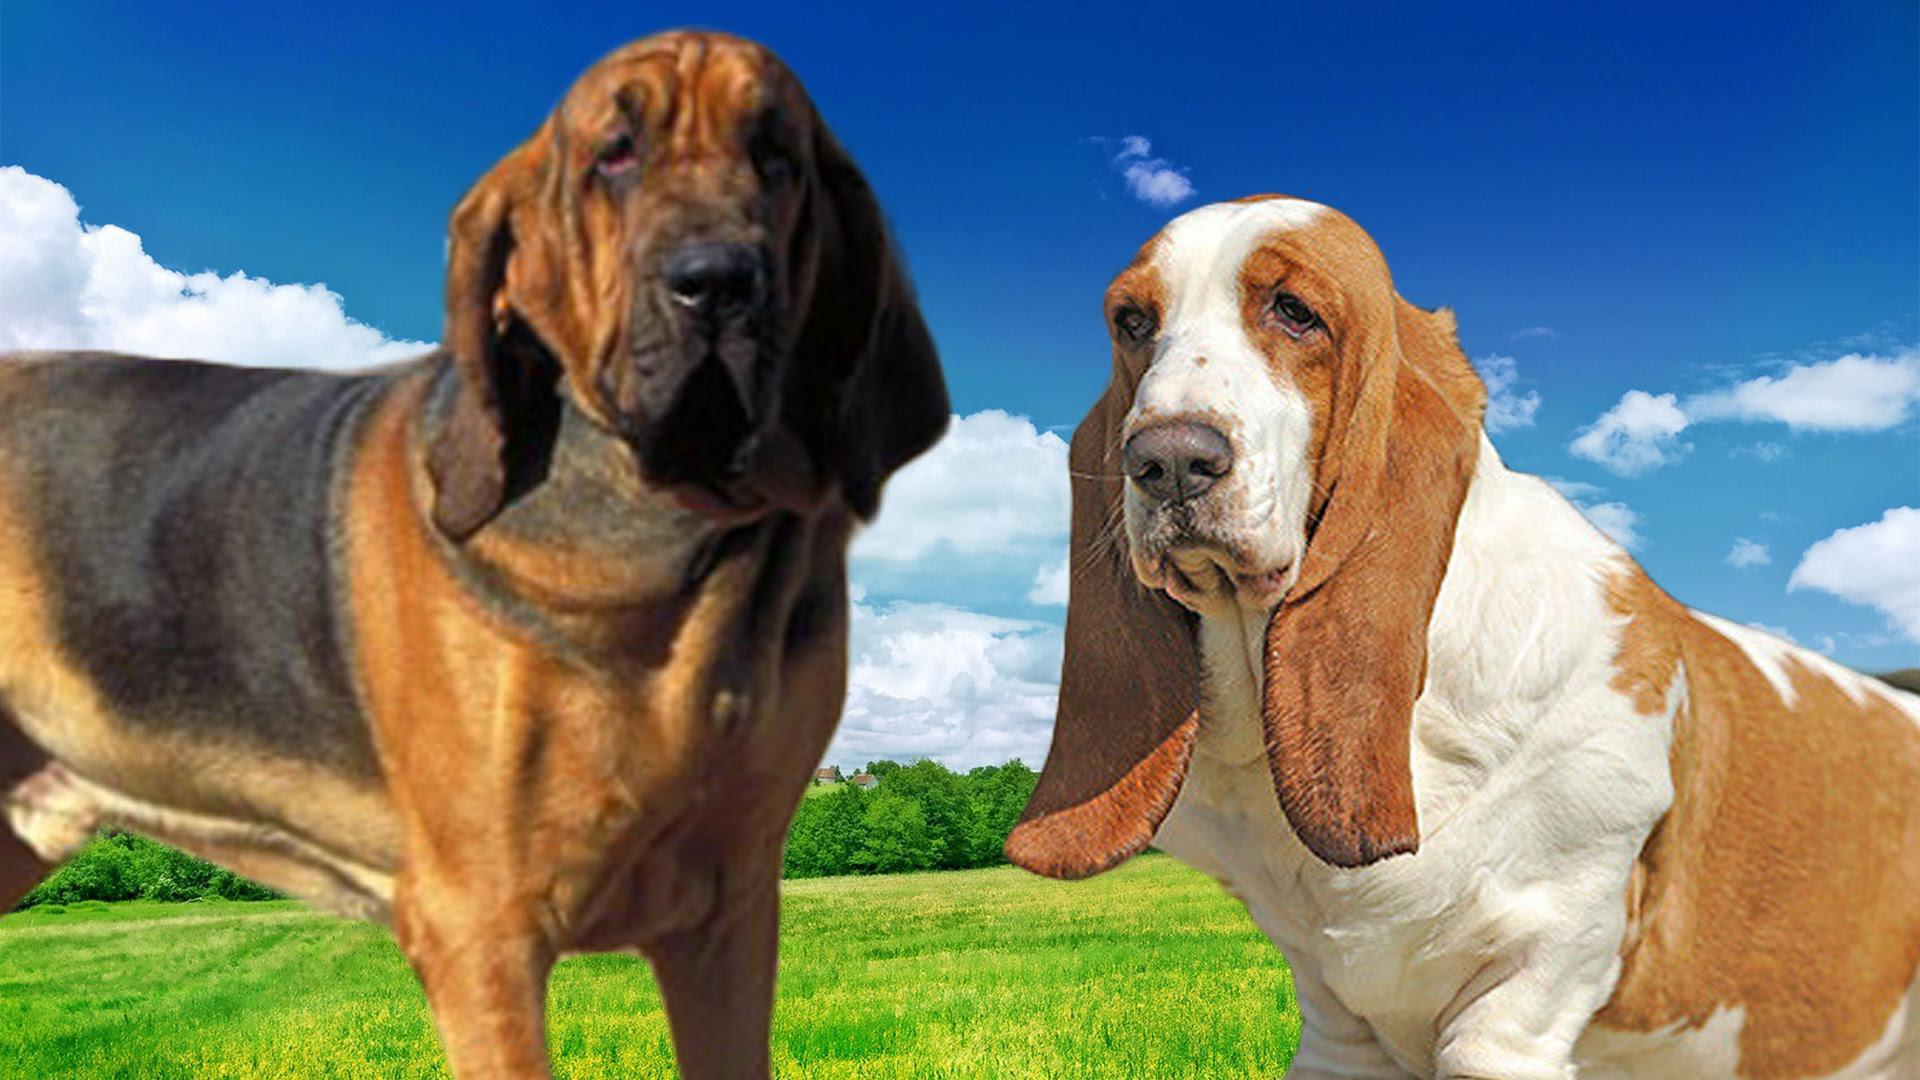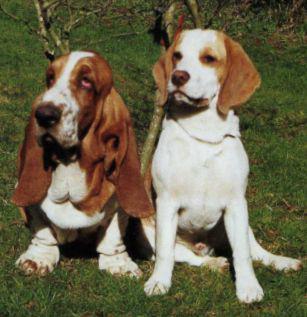The first image is the image on the left, the second image is the image on the right. Assess this claim about the two images: "There are at most two dogs.". Correct or not? Answer yes or no. No. The first image is the image on the left, the second image is the image on the right. Examine the images to the left and right. Is the description "There is atleast one dog present that is not a bloodhound." accurate? Answer yes or no. Yes. 